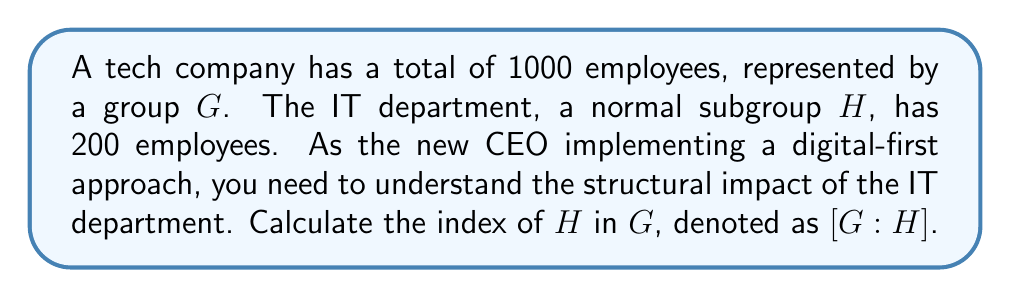Give your solution to this math problem. To solve this problem, we need to understand the concept of index in group theory and how it applies to our company structure:

1. The index of a subgroup $H$ in a group $G$, denoted as $[G:H]$, is defined as the number of distinct left (or right) cosets of $H$ in $G$.

2. For finite groups, the index is equal to the quotient of the orders of the groups:

   $$[G:H] = \frac{|G|}{|H|}$$

   Where $|G|$ is the order (number of elements) of group $G$, and $|H|$ is the order of subgroup $H$.

3. In our case:
   - $|G| = 1000$ (total number of employees)
   - $|H| = 200$ (number of employees in the IT department)

4. Applying the formula:

   $$[G:H] = \frac{|G|}{|H|} = \frac{1000}{200} = 5$$

5. Interpretation: This means there are 5 distinct cosets of the IT department in the company structure. In the context of our digital-first approach, it suggests that the IT department's influence extends to 1/5 of the company's structure, indicating potential areas for digital integration across other departments.
Answer: $[G:H] = 5$ 